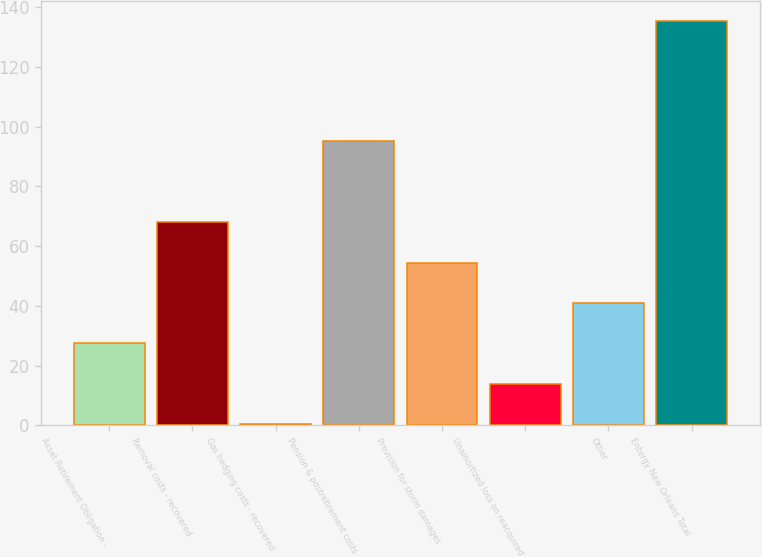Convert chart. <chart><loc_0><loc_0><loc_500><loc_500><bar_chart><fcel>Asset Retirement Obligation -<fcel>Removal costs - recovered<fcel>Gas hedging costs - recovered<fcel>Pension & postretirement costs<fcel>Provision for storm damages<fcel>Unamortized loss on reacquired<fcel>Other<fcel>Entergy New Orleans Total<nl><fcel>27.46<fcel>67.9<fcel>0.5<fcel>95.3<fcel>54.42<fcel>13.98<fcel>40.94<fcel>135.3<nl></chart> 